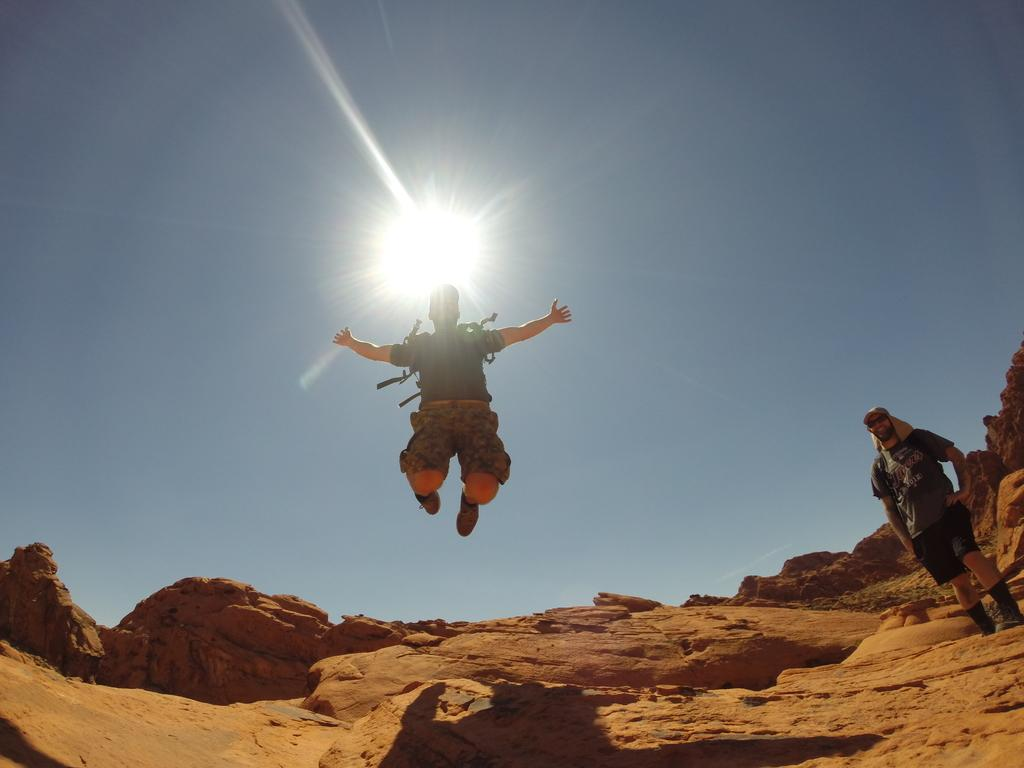What is happening in the center of the image? There is a person in the air in the center of the image. Can you describe the person on the right side of the image? There is a person standing on the ground on the right side of the image. What can be seen in the background of the image? The sky is visible in the background of the image. What type of poison is being used by the person in the air in the image? There is no poison present in the image; it features two people, one in the air and the other on the ground. What kind of pancake can be seen on the person standing on the ground in the image? There is no pancake present in the image; the person standing on the ground is not holding or wearing any food items. 